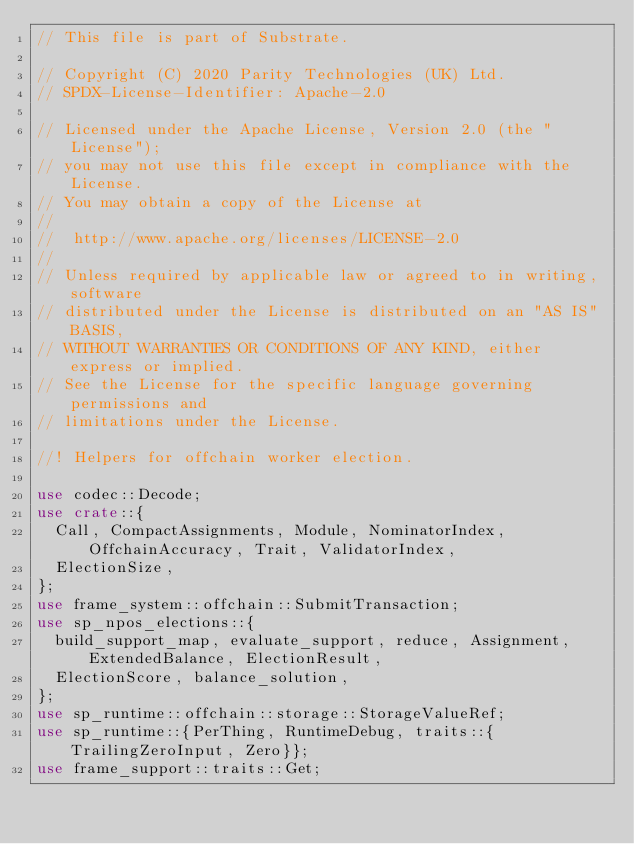Convert code to text. <code><loc_0><loc_0><loc_500><loc_500><_Rust_>// This file is part of Substrate.

// Copyright (C) 2020 Parity Technologies (UK) Ltd.
// SPDX-License-Identifier: Apache-2.0

// Licensed under the Apache License, Version 2.0 (the "License");
// you may not use this file except in compliance with the License.
// You may obtain a copy of the License at
//
// 	http://www.apache.org/licenses/LICENSE-2.0
//
// Unless required by applicable law or agreed to in writing, software
// distributed under the License is distributed on an "AS IS" BASIS,
// WITHOUT WARRANTIES OR CONDITIONS OF ANY KIND, either express or implied.
// See the License for the specific language governing permissions and
// limitations under the License.

//! Helpers for offchain worker election.

use codec::Decode;
use crate::{
	Call, CompactAssignments, Module, NominatorIndex, OffchainAccuracy, Trait, ValidatorIndex,
	ElectionSize,
};
use frame_system::offchain::SubmitTransaction;
use sp_npos_elections::{
	build_support_map, evaluate_support, reduce, Assignment, ExtendedBalance, ElectionResult,
	ElectionScore, balance_solution,
};
use sp_runtime::offchain::storage::StorageValueRef;
use sp_runtime::{PerThing, RuntimeDebug, traits::{TrailingZeroInput, Zero}};
use frame_support::traits::Get;</code> 